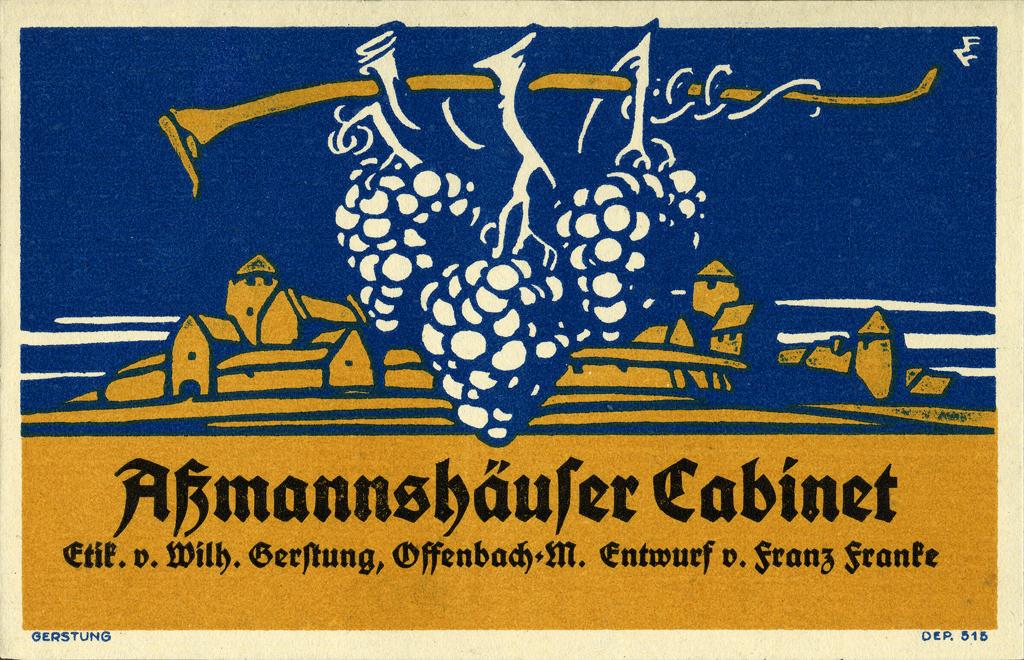What is the second word in the first line of large text?
Make the answer very short. Cabinet. What is the name in bolded text?
Give a very brief answer. Akmannshaufer cabinet. 